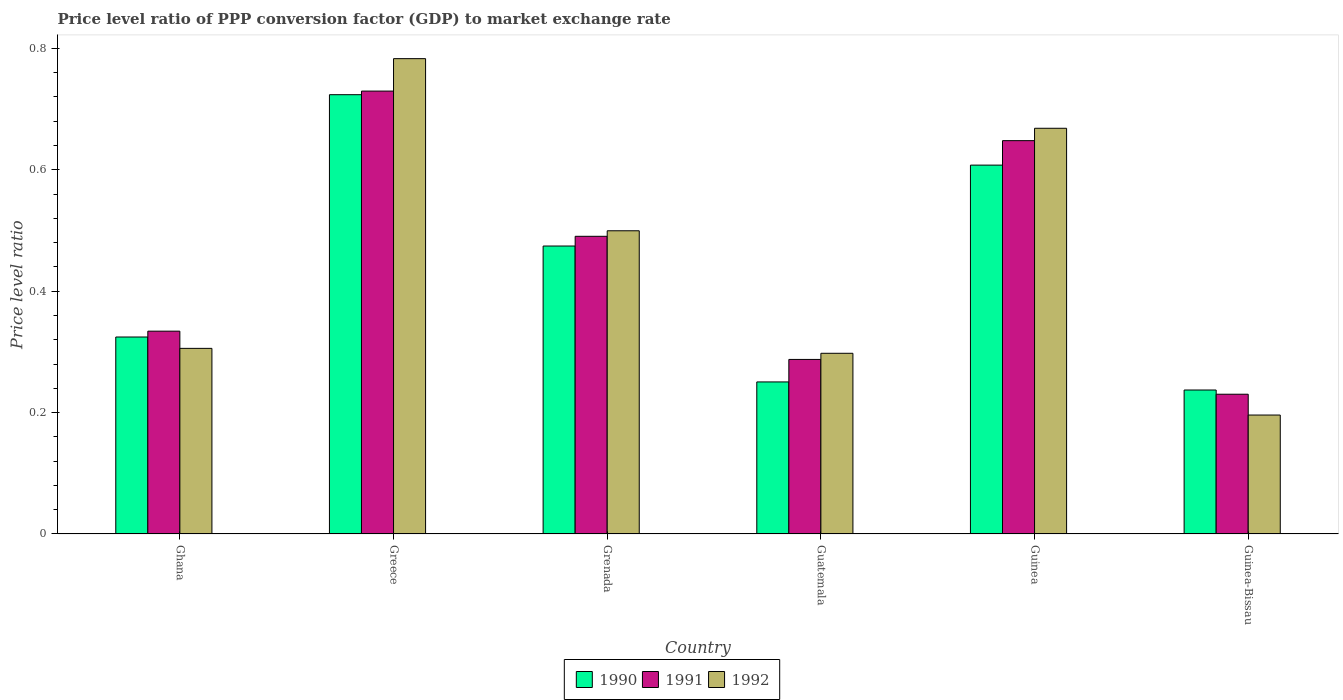How many groups of bars are there?
Your response must be concise. 6. What is the label of the 3rd group of bars from the left?
Keep it short and to the point. Grenada. What is the price level ratio in 1992 in Guinea-Bissau?
Your answer should be compact. 0.2. Across all countries, what is the maximum price level ratio in 1992?
Offer a very short reply. 0.78. Across all countries, what is the minimum price level ratio in 1992?
Your answer should be compact. 0.2. In which country was the price level ratio in 1992 maximum?
Your answer should be compact. Greece. In which country was the price level ratio in 1992 minimum?
Your response must be concise. Guinea-Bissau. What is the total price level ratio in 1992 in the graph?
Make the answer very short. 2.75. What is the difference between the price level ratio in 1991 in Ghana and that in Greece?
Ensure brevity in your answer.  -0.4. What is the difference between the price level ratio in 1992 in Grenada and the price level ratio in 1991 in Guatemala?
Keep it short and to the point. 0.21. What is the average price level ratio in 1992 per country?
Offer a terse response. 0.46. What is the difference between the price level ratio of/in 1992 and price level ratio of/in 1991 in Ghana?
Make the answer very short. -0.03. What is the ratio of the price level ratio in 1991 in Greece to that in Guinea-Bissau?
Provide a short and direct response. 3.17. Is the price level ratio in 1992 in Greece less than that in Grenada?
Provide a short and direct response. No. What is the difference between the highest and the second highest price level ratio in 1991?
Your response must be concise. 0.08. What is the difference between the highest and the lowest price level ratio in 1992?
Give a very brief answer. 0.59. In how many countries, is the price level ratio in 1991 greater than the average price level ratio in 1991 taken over all countries?
Provide a succinct answer. 3. What does the 1st bar from the left in Ghana represents?
Your answer should be compact. 1990. What does the 1st bar from the right in Guatemala represents?
Your response must be concise. 1992. Where does the legend appear in the graph?
Give a very brief answer. Bottom center. How are the legend labels stacked?
Your answer should be very brief. Horizontal. What is the title of the graph?
Give a very brief answer. Price level ratio of PPP conversion factor (GDP) to market exchange rate. What is the label or title of the Y-axis?
Your response must be concise. Price level ratio. What is the Price level ratio in 1990 in Ghana?
Offer a terse response. 0.32. What is the Price level ratio of 1991 in Ghana?
Provide a succinct answer. 0.33. What is the Price level ratio of 1992 in Ghana?
Give a very brief answer. 0.31. What is the Price level ratio of 1990 in Greece?
Keep it short and to the point. 0.72. What is the Price level ratio in 1991 in Greece?
Provide a succinct answer. 0.73. What is the Price level ratio in 1992 in Greece?
Your answer should be compact. 0.78. What is the Price level ratio of 1990 in Grenada?
Offer a terse response. 0.47. What is the Price level ratio in 1991 in Grenada?
Keep it short and to the point. 0.49. What is the Price level ratio in 1992 in Grenada?
Provide a succinct answer. 0.5. What is the Price level ratio of 1990 in Guatemala?
Provide a short and direct response. 0.25. What is the Price level ratio in 1991 in Guatemala?
Offer a terse response. 0.29. What is the Price level ratio in 1992 in Guatemala?
Provide a short and direct response. 0.3. What is the Price level ratio of 1990 in Guinea?
Your answer should be compact. 0.61. What is the Price level ratio of 1991 in Guinea?
Your answer should be compact. 0.65. What is the Price level ratio in 1992 in Guinea?
Ensure brevity in your answer.  0.67. What is the Price level ratio of 1990 in Guinea-Bissau?
Offer a terse response. 0.24. What is the Price level ratio of 1991 in Guinea-Bissau?
Keep it short and to the point. 0.23. What is the Price level ratio of 1992 in Guinea-Bissau?
Your answer should be very brief. 0.2. Across all countries, what is the maximum Price level ratio of 1990?
Ensure brevity in your answer.  0.72. Across all countries, what is the maximum Price level ratio of 1991?
Make the answer very short. 0.73. Across all countries, what is the maximum Price level ratio of 1992?
Your response must be concise. 0.78. Across all countries, what is the minimum Price level ratio of 1990?
Offer a very short reply. 0.24. Across all countries, what is the minimum Price level ratio of 1991?
Offer a very short reply. 0.23. Across all countries, what is the minimum Price level ratio in 1992?
Your response must be concise. 0.2. What is the total Price level ratio in 1990 in the graph?
Offer a very short reply. 2.62. What is the total Price level ratio in 1991 in the graph?
Provide a short and direct response. 2.72. What is the total Price level ratio of 1992 in the graph?
Your response must be concise. 2.75. What is the difference between the Price level ratio in 1990 in Ghana and that in Greece?
Offer a very short reply. -0.4. What is the difference between the Price level ratio of 1991 in Ghana and that in Greece?
Give a very brief answer. -0.4. What is the difference between the Price level ratio in 1992 in Ghana and that in Greece?
Provide a succinct answer. -0.48. What is the difference between the Price level ratio of 1990 in Ghana and that in Grenada?
Give a very brief answer. -0.15. What is the difference between the Price level ratio of 1991 in Ghana and that in Grenada?
Give a very brief answer. -0.16. What is the difference between the Price level ratio in 1992 in Ghana and that in Grenada?
Provide a short and direct response. -0.19. What is the difference between the Price level ratio in 1990 in Ghana and that in Guatemala?
Offer a terse response. 0.07. What is the difference between the Price level ratio of 1991 in Ghana and that in Guatemala?
Offer a terse response. 0.05. What is the difference between the Price level ratio of 1992 in Ghana and that in Guatemala?
Provide a short and direct response. 0.01. What is the difference between the Price level ratio of 1990 in Ghana and that in Guinea?
Provide a succinct answer. -0.28. What is the difference between the Price level ratio of 1991 in Ghana and that in Guinea?
Keep it short and to the point. -0.31. What is the difference between the Price level ratio in 1992 in Ghana and that in Guinea?
Give a very brief answer. -0.36. What is the difference between the Price level ratio of 1990 in Ghana and that in Guinea-Bissau?
Your response must be concise. 0.09. What is the difference between the Price level ratio in 1991 in Ghana and that in Guinea-Bissau?
Your answer should be compact. 0.1. What is the difference between the Price level ratio of 1992 in Ghana and that in Guinea-Bissau?
Provide a succinct answer. 0.11. What is the difference between the Price level ratio of 1990 in Greece and that in Grenada?
Your answer should be very brief. 0.25. What is the difference between the Price level ratio in 1991 in Greece and that in Grenada?
Your answer should be very brief. 0.24. What is the difference between the Price level ratio in 1992 in Greece and that in Grenada?
Make the answer very short. 0.28. What is the difference between the Price level ratio of 1990 in Greece and that in Guatemala?
Make the answer very short. 0.47. What is the difference between the Price level ratio in 1991 in Greece and that in Guatemala?
Provide a succinct answer. 0.44. What is the difference between the Price level ratio of 1992 in Greece and that in Guatemala?
Your answer should be compact. 0.49. What is the difference between the Price level ratio in 1990 in Greece and that in Guinea?
Keep it short and to the point. 0.12. What is the difference between the Price level ratio in 1991 in Greece and that in Guinea?
Give a very brief answer. 0.08. What is the difference between the Price level ratio of 1992 in Greece and that in Guinea?
Your answer should be compact. 0.11. What is the difference between the Price level ratio in 1990 in Greece and that in Guinea-Bissau?
Provide a succinct answer. 0.49. What is the difference between the Price level ratio in 1991 in Greece and that in Guinea-Bissau?
Provide a short and direct response. 0.5. What is the difference between the Price level ratio of 1992 in Greece and that in Guinea-Bissau?
Make the answer very short. 0.59. What is the difference between the Price level ratio of 1990 in Grenada and that in Guatemala?
Your answer should be very brief. 0.22. What is the difference between the Price level ratio in 1991 in Grenada and that in Guatemala?
Give a very brief answer. 0.2. What is the difference between the Price level ratio in 1992 in Grenada and that in Guatemala?
Ensure brevity in your answer.  0.2. What is the difference between the Price level ratio in 1990 in Grenada and that in Guinea?
Your answer should be compact. -0.13. What is the difference between the Price level ratio in 1991 in Grenada and that in Guinea?
Make the answer very short. -0.16. What is the difference between the Price level ratio of 1992 in Grenada and that in Guinea?
Offer a very short reply. -0.17. What is the difference between the Price level ratio of 1990 in Grenada and that in Guinea-Bissau?
Ensure brevity in your answer.  0.24. What is the difference between the Price level ratio of 1991 in Grenada and that in Guinea-Bissau?
Keep it short and to the point. 0.26. What is the difference between the Price level ratio in 1992 in Grenada and that in Guinea-Bissau?
Make the answer very short. 0.3. What is the difference between the Price level ratio in 1990 in Guatemala and that in Guinea?
Offer a very short reply. -0.36. What is the difference between the Price level ratio of 1991 in Guatemala and that in Guinea?
Offer a very short reply. -0.36. What is the difference between the Price level ratio in 1992 in Guatemala and that in Guinea?
Your answer should be compact. -0.37. What is the difference between the Price level ratio of 1990 in Guatemala and that in Guinea-Bissau?
Give a very brief answer. 0.01. What is the difference between the Price level ratio in 1991 in Guatemala and that in Guinea-Bissau?
Provide a short and direct response. 0.06. What is the difference between the Price level ratio in 1992 in Guatemala and that in Guinea-Bissau?
Offer a very short reply. 0.1. What is the difference between the Price level ratio of 1990 in Guinea and that in Guinea-Bissau?
Your answer should be very brief. 0.37. What is the difference between the Price level ratio of 1991 in Guinea and that in Guinea-Bissau?
Your response must be concise. 0.42. What is the difference between the Price level ratio in 1992 in Guinea and that in Guinea-Bissau?
Your answer should be compact. 0.47. What is the difference between the Price level ratio in 1990 in Ghana and the Price level ratio in 1991 in Greece?
Keep it short and to the point. -0.41. What is the difference between the Price level ratio in 1990 in Ghana and the Price level ratio in 1992 in Greece?
Keep it short and to the point. -0.46. What is the difference between the Price level ratio in 1991 in Ghana and the Price level ratio in 1992 in Greece?
Your answer should be very brief. -0.45. What is the difference between the Price level ratio in 1990 in Ghana and the Price level ratio in 1991 in Grenada?
Your answer should be compact. -0.17. What is the difference between the Price level ratio of 1990 in Ghana and the Price level ratio of 1992 in Grenada?
Give a very brief answer. -0.17. What is the difference between the Price level ratio of 1991 in Ghana and the Price level ratio of 1992 in Grenada?
Your answer should be very brief. -0.17. What is the difference between the Price level ratio of 1990 in Ghana and the Price level ratio of 1991 in Guatemala?
Your response must be concise. 0.04. What is the difference between the Price level ratio of 1990 in Ghana and the Price level ratio of 1992 in Guatemala?
Give a very brief answer. 0.03. What is the difference between the Price level ratio in 1991 in Ghana and the Price level ratio in 1992 in Guatemala?
Offer a terse response. 0.04. What is the difference between the Price level ratio of 1990 in Ghana and the Price level ratio of 1991 in Guinea?
Your answer should be very brief. -0.32. What is the difference between the Price level ratio in 1990 in Ghana and the Price level ratio in 1992 in Guinea?
Ensure brevity in your answer.  -0.34. What is the difference between the Price level ratio in 1991 in Ghana and the Price level ratio in 1992 in Guinea?
Ensure brevity in your answer.  -0.33. What is the difference between the Price level ratio in 1990 in Ghana and the Price level ratio in 1991 in Guinea-Bissau?
Ensure brevity in your answer.  0.09. What is the difference between the Price level ratio of 1990 in Ghana and the Price level ratio of 1992 in Guinea-Bissau?
Offer a very short reply. 0.13. What is the difference between the Price level ratio in 1991 in Ghana and the Price level ratio in 1992 in Guinea-Bissau?
Make the answer very short. 0.14. What is the difference between the Price level ratio of 1990 in Greece and the Price level ratio of 1991 in Grenada?
Offer a terse response. 0.23. What is the difference between the Price level ratio of 1990 in Greece and the Price level ratio of 1992 in Grenada?
Keep it short and to the point. 0.22. What is the difference between the Price level ratio in 1991 in Greece and the Price level ratio in 1992 in Grenada?
Provide a succinct answer. 0.23. What is the difference between the Price level ratio of 1990 in Greece and the Price level ratio of 1991 in Guatemala?
Keep it short and to the point. 0.44. What is the difference between the Price level ratio of 1990 in Greece and the Price level ratio of 1992 in Guatemala?
Make the answer very short. 0.43. What is the difference between the Price level ratio of 1991 in Greece and the Price level ratio of 1992 in Guatemala?
Ensure brevity in your answer.  0.43. What is the difference between the Price level ratio in 1990 in Greece and the Price level ratio in 1991 in Guinea?
Provide a succinct answer. 0.08. What is the difference between the Price level ratio of 1990 in Greece and the Price level ratio of 1992 in Guinea?
Provide a succinct answer. 0.06. What is the difference between the Price level ratio in 1991 in Greece and the Price level ratio in 1992 in Guinea?
Provide a short and direct response. 0.06. What is the difference between the Price level ratio in 1990 in Greece and the Price level ratio in 1991 in Guinea-Bissau?
Your answer should be very brief. 0.49. What is the difference between the Price level ratio in 1990 in Greece and the Price level ratio in 1992 in Guinea-Bissau?
Your answer should be very brief. 0.53. What is the difference between the Price level ratio of 1991 in Greece and the Price level ratio of 1992 in Guinea-Bissau?
Your answer should be compact. 0.53. What is the difference between the Price level ratio in 1990 in Grenada and the Price level ratio in 1991 in Guatemala?
Your answer should be compact. 0.19. What is the difference between the Price level ratio in 1990 in Grenada and the Price level ratio in 1992 in Guatemala?
Keep it short and to the point. 0.18. What is the difference between the Price level ratio of 1991 in Grenada and the Price level ratio of 1992 in Guatemala?
Provide a succinct answer. 0.19. What is the difference between the Price level ratio in 1990 in Grenada and the Price level ratio in 1991 in Guinea?
Ensure brevity in your answer.  -0.17. What is the difference between the Price level ratio in 1990 in Grenada and the Price level ratio in 1992 in Guinea?
Your answer should be compact. -0.19. What is the difference between the Price level ratio of 1991 in Grenada and the Price level ratio of 1992 in Guinea?
Ensure brevity in your answer.  -0.18. What is the difference between the Price level ratio in 1990 in Grenada and the Price level ratio in 1991 in Guinea-Bissau?
Offer a very short reply. 0.24. What is the difference between the Price level ratio of 1990 in Grenada and the Price level ratio of 1992 in Guinea-Bissau?
Give a very brief answer. 0.28. What is the difference between the Price level ratio of 1991 in Grenada and the Price level ratio of 1992 in Guinea-Bissau?
Provide a succinct answer. 0.29. What is the difference between the Price level ratio in 1990 in Guatemala and the Price level ratio in 1991 in Guinea?
Keep it short and to the point. -0.4. What is the difference between the Price level ratio of 1990 in Guatemala and the Price level ratio of 1992 in Guinea?
Your response must be concise. -0.42. What is the difference between the Price level ratio in 1991 in Guatemala and the Price level ratio in 1992 in Guinea?
Your answer should be compact. -0.38. What is the difference between the Price level ratio in 1990 in Guatemala and the Price level ratio in 1991 in Guinea-Bissau?
Provide a succinct answer. 0.02. What is the difference between the Price level ratio of 1990 in Guatemala and the Price level ratio of 1992 in Guinea-Bissau?
Your response must be concise. 0.05. What is the difference between the Price level ratio in 1991 in Guatemala and the Price level ratio in 1992 in Guinea-Bissau?
Make the answer very short. 0.09. What is the difference between the Price level ratio of 1990 in Guinea and the Price level ratio of 1991 in Guinea-Bissau?
Provide a succinct answer. 0.38. What is the difference between the Price level ratio in 1990 in Guinea and the Price level ratio in 1992 in Guinea-Bissau?
Offer a very short reply. 0.41. What is the difference between the Price level ratio of 1991 in Guinea and the Price level ratio of 1992 in Guinea-Bissau?
Ensure brevity in your answer.  0.45. What is the average Price level ratio in 1990 per country?
Offer a very short reply. 0.44. What is the average Price level ratio in 1991 per country?
Your answer should be very brief. 0.45. What is the average Price level ratio in 1992 per country?
Your response must be concise. 0.46. What is the difference between the Price level ratio in 1990 and Price level ratio in 1991 in Ghana?
Your response must be concise. -0.01. What is the difference between the Price level ratio of 1990 and Price level ratio of 1992 in Ghana?
Give a very brief answer. 0.02. What is the difference between the Price level ratio in 1991 and Price level ratio in 1992 in Ghana?
Give a very brief answer. 0.03. What is the difference between the Price level ratio in 1990 and Price level ratio in 1991 in Greece?
Your answer should be very brief. -0.01. What is the difference between the Price level ratio of 1990 and Price level ratio of 1992 in Greece?
Your answer should be compact. -0.06. What is the difference between the Price level ratio in 1991 and Price level ratio in 1992 in Greece?
Give a very brief answer. -0.05. What is the difference between the Price level ratio in 1990 and Price level ratio in 1991 in Grenada?
Keep it short and to the point. -0.02. What is the difference between the Price level ratio of 1990 and Price level ratio of 1992 in Grenada?
Offer a terse response. -0.03. What is the difference between the Price level ratio of 1991 and Price level ratio of 1992 in Grenada?
Offer a terse response. -0.01. What is the difference between the Price level ratio of 1990 and Price level ratio of 1991 in Guatemala?
Your answer should be very brief. -0.04. What is the difference between the Price level ratio of 1990 and Price level ratio of 1992 in Guatemala?
Your response must be concise. -0.05. What is the difference between the Price level ratio in 1991 and Price level ratio in 1992 in Guatemala?
Give a very brief answer. -0.01. What is the difference between the Price level ratio in 1990 and Price level ratio in 1991 in Guinea?
Your answer should be compact. -0.04. What is the difference between the Price level ratio in 1990 and Price level ratio in 1992 in Guinea?
Make the answer very short. -0.06. What is the difference between the Price level ratio in 1991 and Price level ratio in 1992 in Guinea?
Offer a very short reply. -0.02. What is the difference between the Price level ratio of 1990 and Price level ratio of 1991 in Guinea-Bissau?
Offer a very short reply. 0.01. What is the difference between the Price level ratio of 1990 and Price level ratio of 1992 in Guinea-Bissau?
Your answer should be very brief. 0.04. What is the difference between the Price level ratio of 1991 and Price level ratio of 1992 in Guinea-Bissau?
Offer a very short reply. 0.03. What is the ratio of the Price level ratio in 1990 in Ghana to that in Greece?
Offer a very short reply. 0.45. What is the ratio of the Price level ratio of 1991 in Ghana to that in Greece?
Your answer should be compact. 0.46. What is the ratio of the Price level ratio of 1992 in Ghana to that in Greece?
Offer a very short reply. 0.39. What is the ratio of the Price level ratio in 1990 in Ghana to that in Grenada?
Provide a short and direct response. 0.68. What is the ratio of the Price level ratio of 1991 in Ghana to that in Grenada?
Provide a short and direct response. 0.68. What is the ratio of the Price level ratio in 1992 in Ghana to that in Grenada?
Make the answer very short. 0.61. What is the ratio of the Price level ratio of 1990 in Ghana to that in Guatemala?
Offer a terse response. 1.3. What is the ratio of the Price level ratio in 1991 in Ghana to that in Guatemala?
Keep it short and to the point. 1.16. What is the ratio of the Price level ratio in 1992 in Ghana to that in Guatemala?
Your response must be concise. 1.03. What is the ratio of the Price level ratio of 1990 in Ghana to that in Guinea?
Ensure brevity in your answer.  0.53. What is the ratio of the Price level ratio in 1991 in Ghana to that in Guinea?
Your answer should be compact. 0.52. What is the ratio of the Price level ratio in 1992 in Ghana to that in Guinea?
Your answer should be very brief. 0.46. What is the ratio of the Price level ratio of 1990 in Ghana to that in Guinea-Bissau?
Ensure brevity in your answer.  1.37. What is the ratio of the Price level ratio of 1991 in Ghana to that in Guinea-Bissau?
Make the answer very short. 1.45. What is the ratio of the Price level ratio of 1992 in Ghana to that in Guinea-Bissau?
Your answer should be very brief. 1.56. What is the ratio of the Price level ratio in 1990 in Greece to that in Grenada?
Offer a very short reply. 1.53. What is the ratio of the Price level ratio in 1991 in Greece to that in Grenada?
Your answer should be very brief. 1.49. What is the ratio of the Price level ratio of 1992 in Greece to that in Grenada?
Provide a succinct answer. 1.57. What is the ratio of the Price level ratio in 1990 in Greece to that in Guatemala?
Offer a very short reply. 2.89. What is the ratio of the Price level ratio of 1991 in Greece to that in Guatemala?
Provide a short and direct response. 2.54. What is the ratio of the Price level ratio in 1992 in Greece to that in Guatemala?
Give a very brief answer. 2.63. What is the ratio of the Price level ratio of 1990 in Greece to that in Guinea?
Offer a very short reply. 1.19. What is the ratio of the Price level ratio of 1991 in Greece to that in Guinea?
Your answer should be very brief. 1.13. What is the ratio of the Price level ratio of 1992 in Greece to that in Guinea?
Keep it short and to the point. 1.17. What is the ratio of the Price level ratio in 1990 in Greece to that in Guinea-Bissau?
Keep it short and to the point. 3.05. What is the ratio of the Price level ratio of 1991 in Greece to that in Guinea-Bissau?
Offer a very short reply. 3.17. What is the ratio of the Price level ratio in 1992 in Greece to that in Guinea-Bissau?
Make the answer very short. 4. What is the ratio of the Price level ratio in 1990 in Grenada to that in Guatemala?
Offer a terse response. 1.89. What is the ratio of the Price level ratio in 1991 in Grenada to that in Guatemala?
Ensure brevity in your answer.  1.71. What is the ratio of the Price level ratio in 1992 in Grenada to that in Guatemala?
Offer a very short reply. 1.68. What is the ratio of the Price level ratio of 1990 in Grenada to that in Guinea?
Offer a very short reply. 0.78. What is the ratio of the Price level ratio in 1991 in Grenada to that in Guinea?
Your response must be concise. 0.76. What is the ratio of the Price level ratio of 1992 in Grenada to that in Guinea?
Provide a short and direct response. 0.75. What is the ratio of the Price level ratio in 1990 in Grenada to that in Guinea-Bissau?
Keep it short and to the point. 2. What is the ratio of the Price level ratio in 1991 in Grenada to that in Guinea-Bissau?
Keep it short and to the point. 2.13. What is the ratio of the Price level ratio in 1992 in Grenada to that in Guinea-Bissau?
Your answer should be compact. 2.55. What is the ratio of the Price level ratio of 1990 in Guatemala to that in Guinea?
Your response must be concise. 0.41. What is the ratio of the Price level ratio of 1991 in Guatemala to that in Guinea?
Keep it short and to the point. 0.44. What is the ratio of the Price level ratio of 1992 in Guatemala to that in Guinea?
Offer a terse response. 0.45. What is the ratio of the Price level ratio in 1990 in Guatemala to that in Guinea-Bissau?
Provide a short and direct response. 1.06. What is the ratio of the Price level ratio in 1991 in Guatemala to that in Guinea-Bissau?
Provide a short and direct response. 1.25. What is the ratio of the Price level ratio of 1992 in Guatemala to that in Guinea-Bissau?
Your answer should be compact. 1.52. What is the ratio of the Price level ratio in 1990 in Guinea to that in Guinea-Bissau?
Your answer should be compact. 2.56. What is the ratio of the Price level ratio of 1991 in Guinea to that in Guinea-Bissau?
Provide a short and direct response. 2.81. What is the ratio of the Price level ratio of 1992 in Guinea to that in Guinea-Bissau?
Provide a short and direct response. 3.41. What is the difference between the highest and the second highest Price level ratio of 1990?
Offer a very short reply. 0.12. What is the difference between the highest and the second highest Price level ratio of 1991?
Your answer should be very brief. 0.08. What is the difference between the highest and the second highest Price level ratio of 1992?
Offer a very short reply. 0.11. What is the difference between the highest and the lowest Price level ratio in 1990?
Offer a very short reply. 0.49. What is the difference between the highest and the lowest Price level ratio in 1991?
Make the answer very short. 0.5. What is the difference between the highest and the lowest Price level ratio of 1992?
Give a very brief answer. 0.59. 